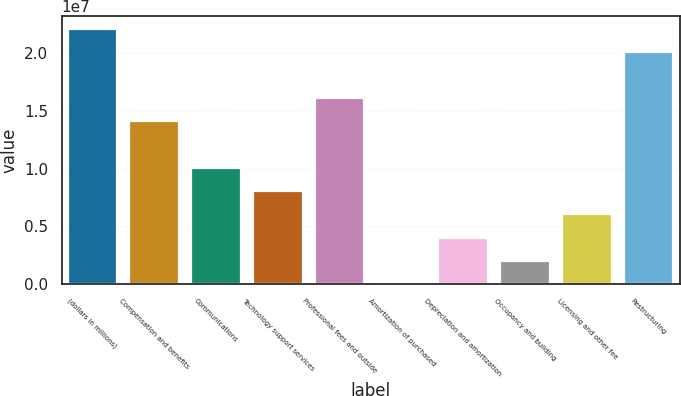<chart> <loc_0><loc_0><loc_500><loc_500><bar_chart><fcel>(dollars in millions)<fcel>Compensation and benefits<fcel>Communications<fcel>Technology support services<fcel>Professional fees and outside<fcel>Amortization of purchased<fcel>Depreciation and amortization<fcel>Occupancy and building<fcel>Licensing and other fee<fcel>Restructuring<nl><fcel>2.21122e+07<fcel>1.40714e+07<fcel>1.0051e+07<fcel>8.0408e+06<fcel>1.60816e+07<fcel>2<fcel>4.0204e+06<fcel>2.0102e+06<fcel>6.0306e+06<fcel>2.0102e+07<nl></chart> 